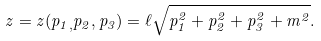<formula> <loc_0><loc_0><loc_500><loc_500>z = z ( p _ { 1 , } p _ { 2 } , p _ { 3 } ) = \ell \sqrt { p _ { 1 } ^ { 2 } + p _ { 2 } ^ { 2 } + p _ { 3 } ^ { 2 } + m ^ { 2 } } .</formula> 